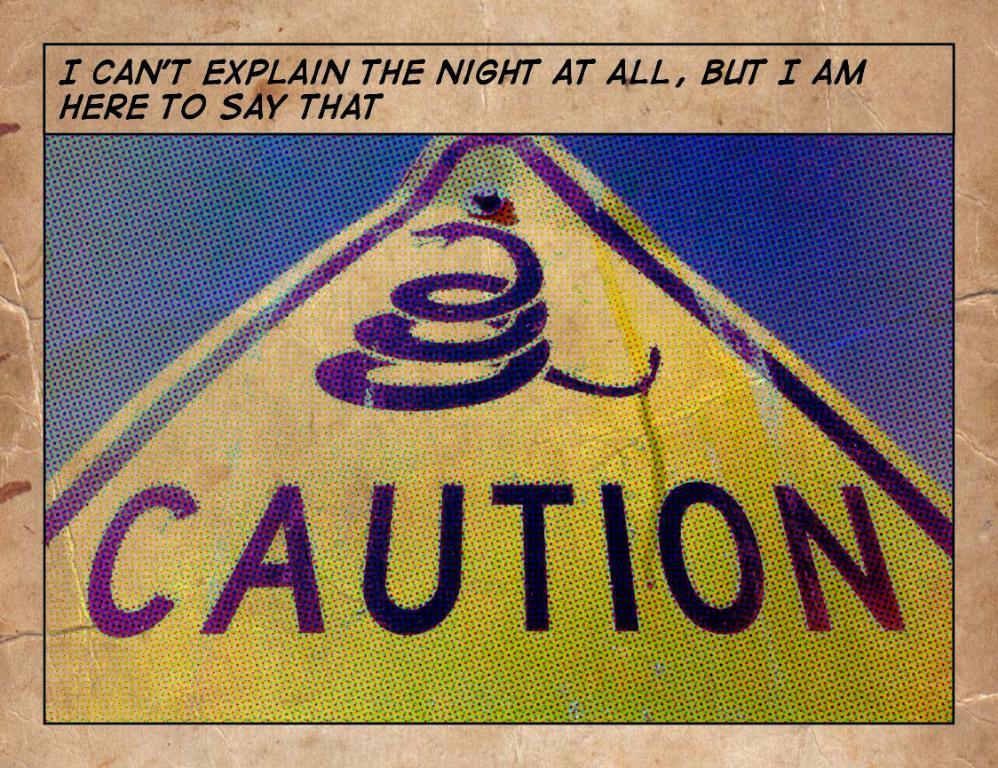Does this sign read "caution"?
Offer a very short reply. Yes. Are there really snakes around that area?
Offer a terse response. Yes. 